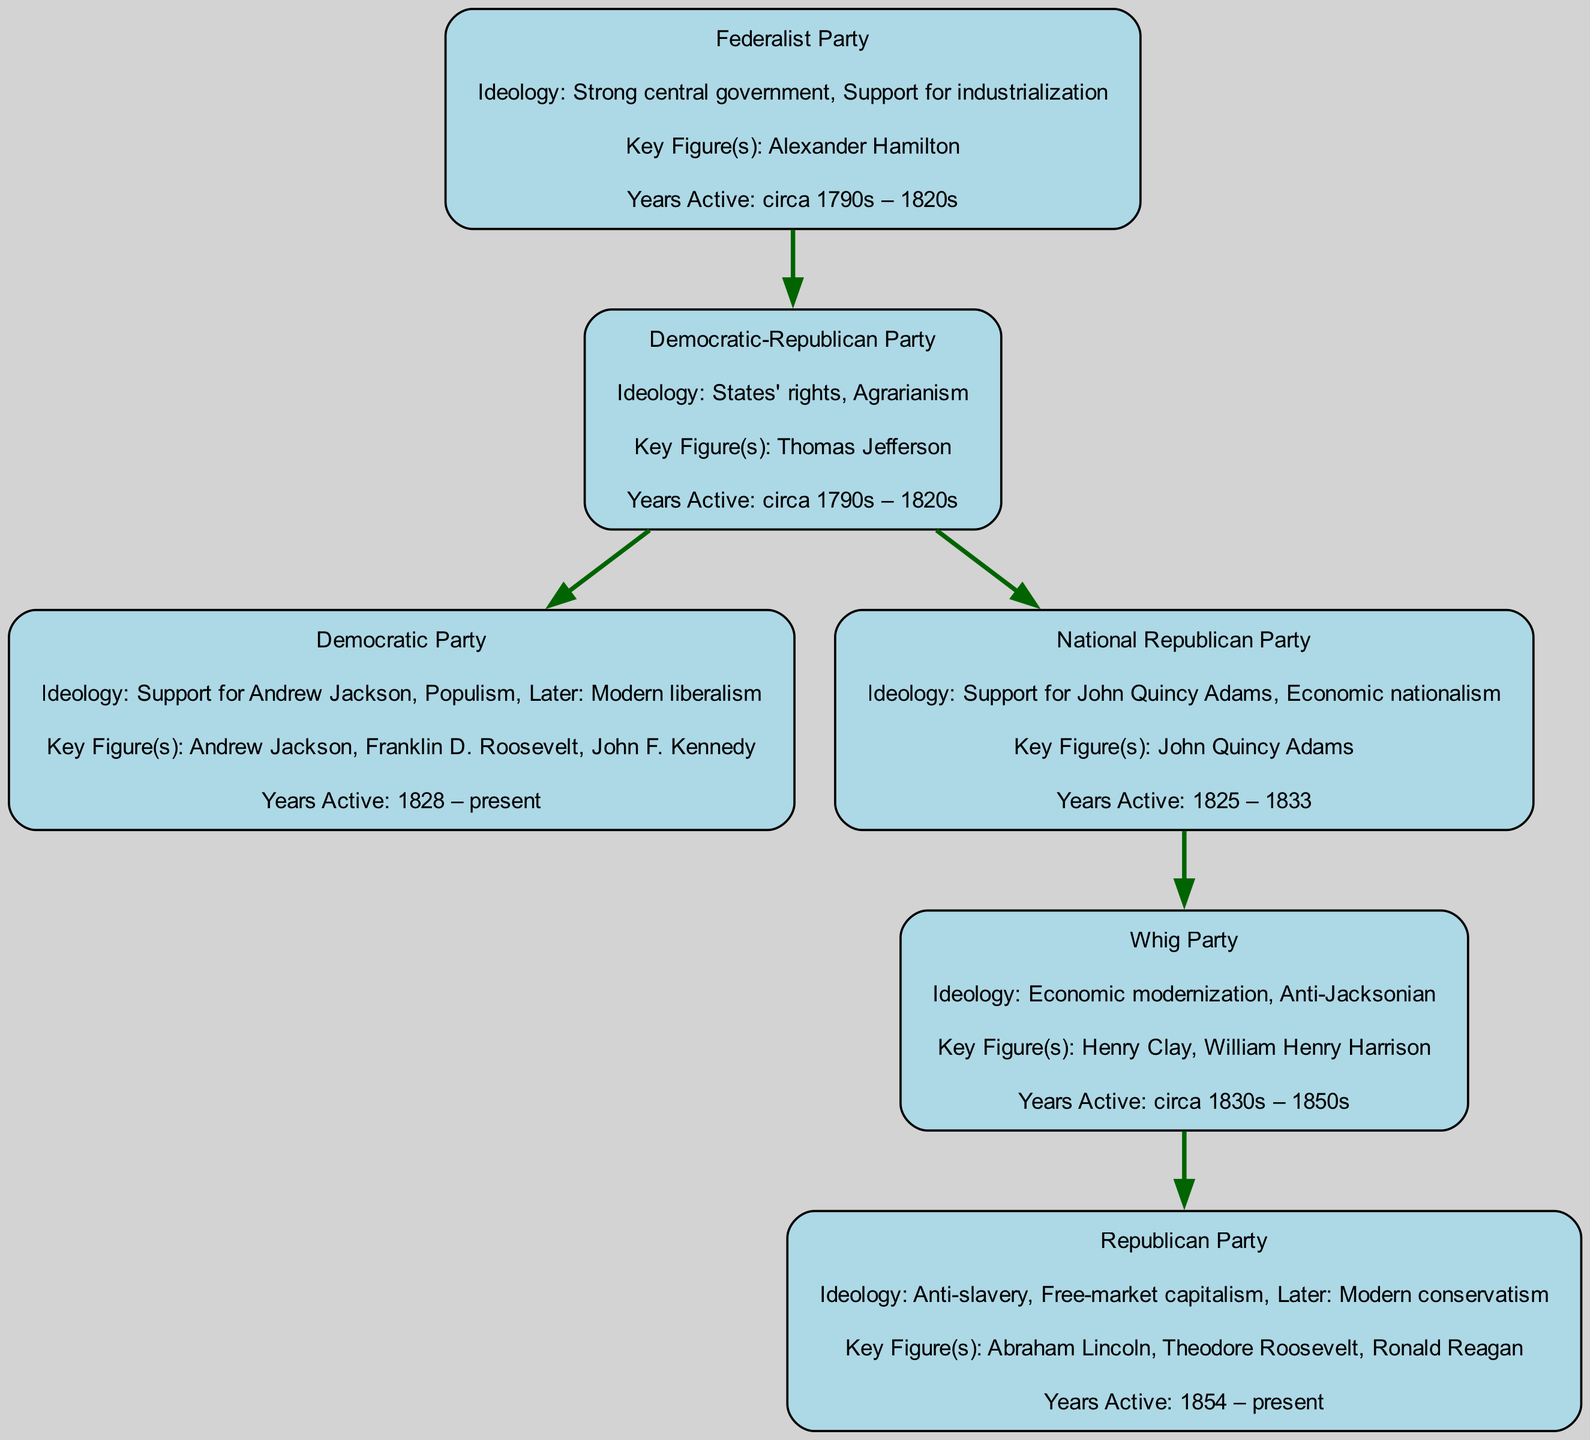What party is associated with the key figure Alexander Hamilton? The diagram shows that the Federalist Party is connected to Alexander Hamilton as its key figure. This relationship is depicted at the starting point of the family tree.
Answer: Federalist Party What ideology is represented by the Democratic Party? According to the diagram, the ideologies of the Democratic Party include support for Andrew Jackson, populism, and later modern liberalism, as listed under its description.
Answer: Support for Andrew Jackson, Populism, Later: Modern liberalism How many key figures are listed under the Republican Party? The Republican Party has three key figures listed in the diagram: Abraham Lincoln, Theodore Roosevelt, and Ronald Reagan. By counting these names, we can conclude there are three key figures total.
Answer: 3 Which party emerged from the National Republican Party? The Whig Party is noted as a sub-branch that emerged from the National Republican Party in the family tree, indicating a direct relationship between these two parties.
Answer: Whig Party What was the years active for the Democratic-Republican Party? The diagram specifies that the Democratic-Republican Party was active from the 1790s to the 1820s, which gives us a time frame for its existence.
Answer: circa 1790s – 1820s Which party is identified as anti-Jacksonian? The diagram shows that the Whig Party is described with the ideology of being anti-Jacksonian, representing a clear stance against Andrew Jackson's policies.
Answer: Whig Party What ideology is shared by both the Federalist Party and the National Republican Party? Both parties share the ideology of economic nationalism, as indicated by the National Republican Party, which originated from the Democratic-Republican Party, which included aspects of strong government present in Federalism.
Answer: Economic nationalism Which political party was founded in 1854? The diagram indicates that the Republican Party was founded in 1854, which situates its formation within the historical timeline of U.S. political parties.
Answer: Republican Party What is the primary ideology of the Whig Party? The ideology of the Whig Party is described as economic modernization and anti-Jacksonian, which captures the essence of its political stance during its active years.
Answer: Economic modernization, Anti-Jacksonian 